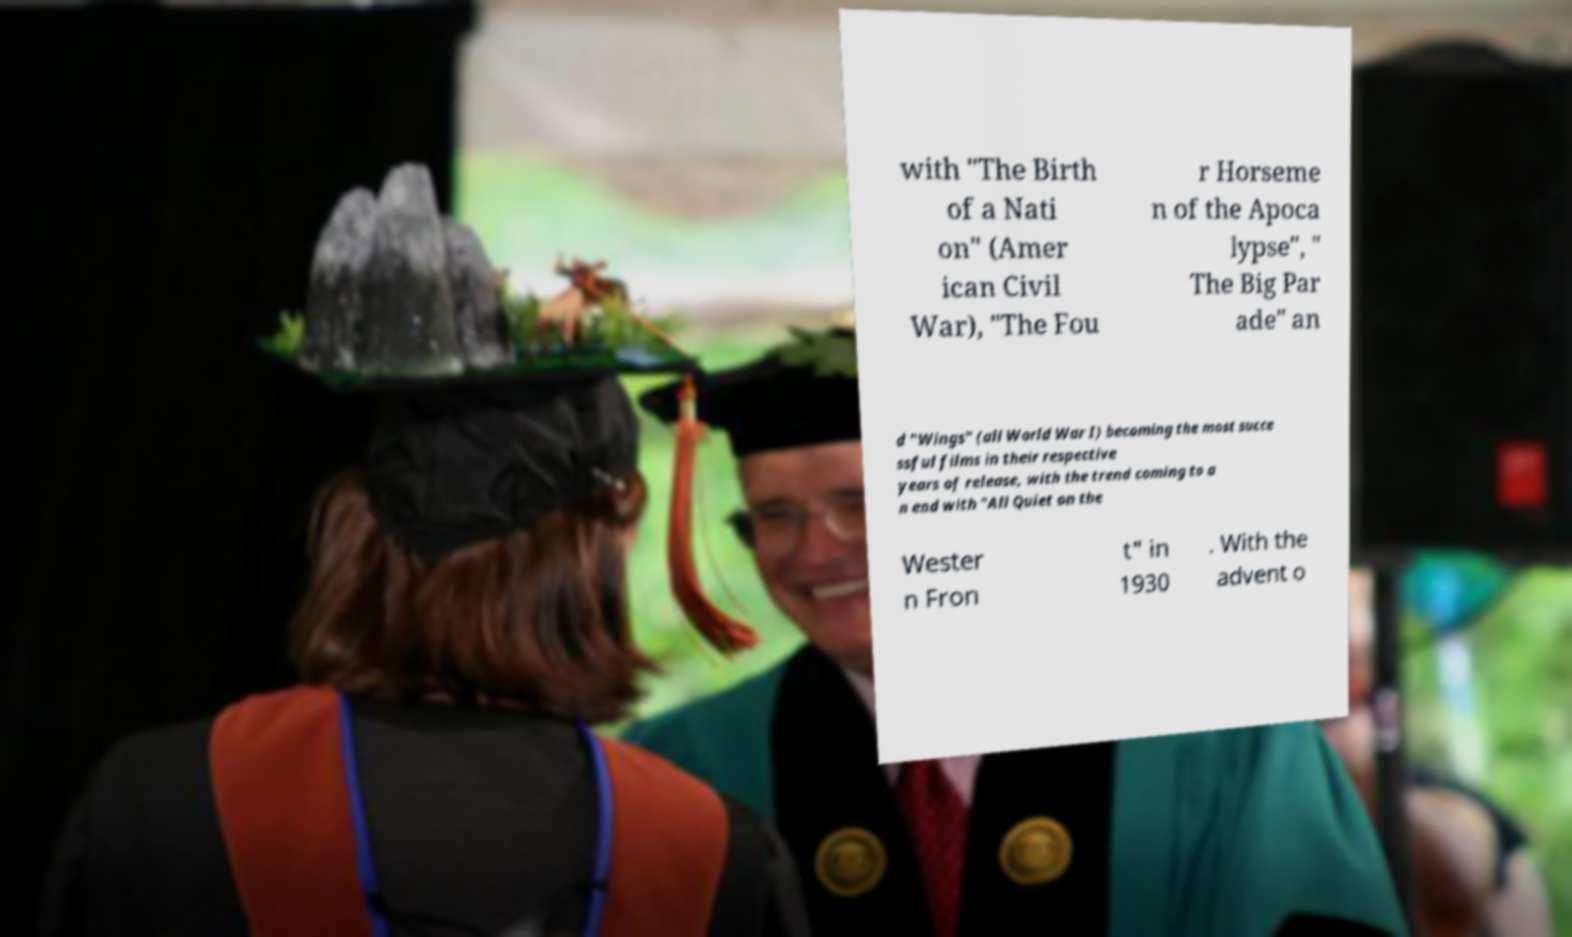Could you assist in decoding the text presented in this image and type it out clearly? with "The Birth of a Nati on" (Amer ican Civil War), "The Fou r Horseme n of the Apoca lypse", " The Big Par ade" an d "Wings" (all World War I) becoming the most succe ssful films in their respective years of release, with the trend coming to a n end with "All Quiet on the Wester n Fron t" in 1930 . With the advent o 